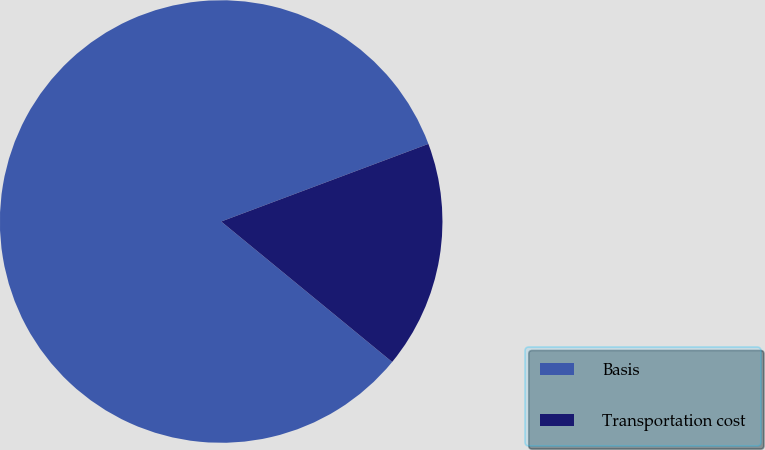Convert chart to OTSL. <chart><loc_0><loc_0><loc_500><loc_500><pie_chart><fcel>Basis<fcel>Transportation cost<nl><fcel>83.35%<fcel>16.65%<nl></chart> 